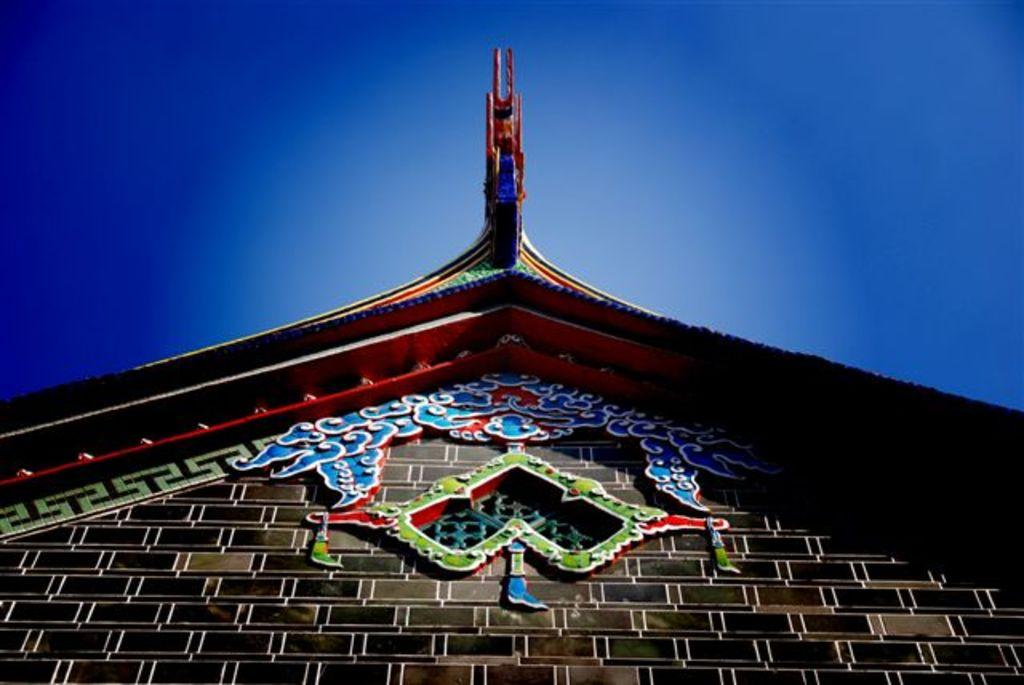What type of structure can be seen in the image? There is a wall in the image. What can be observed about the roof in the image? The roof in the image is multi-colored. Are there any additional features on the wall? Yes, there is decoration on the wall. What is visible at the top of the image? The sky is visible at the top of the image, and it is clear. What type of plant is growing on the wall in the image? There is no plant growing on the wall in the image. How does the self-awareness of the wall contribute to the overall aesthetic of the image? The wall in the image does not have self-awareness, as it is an inanimate object. 